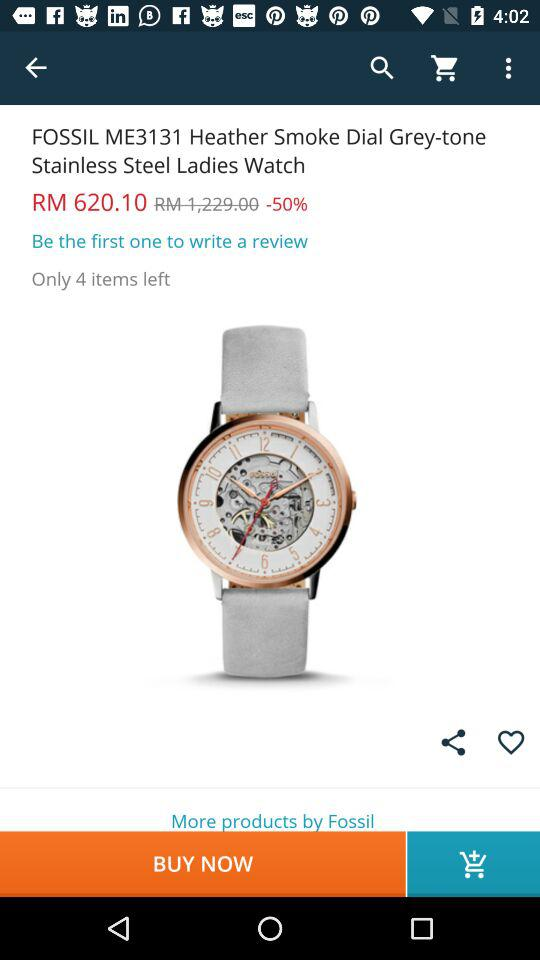What is the percentage discount on the watch?
Answer the question using a single word or phrase. 50% 